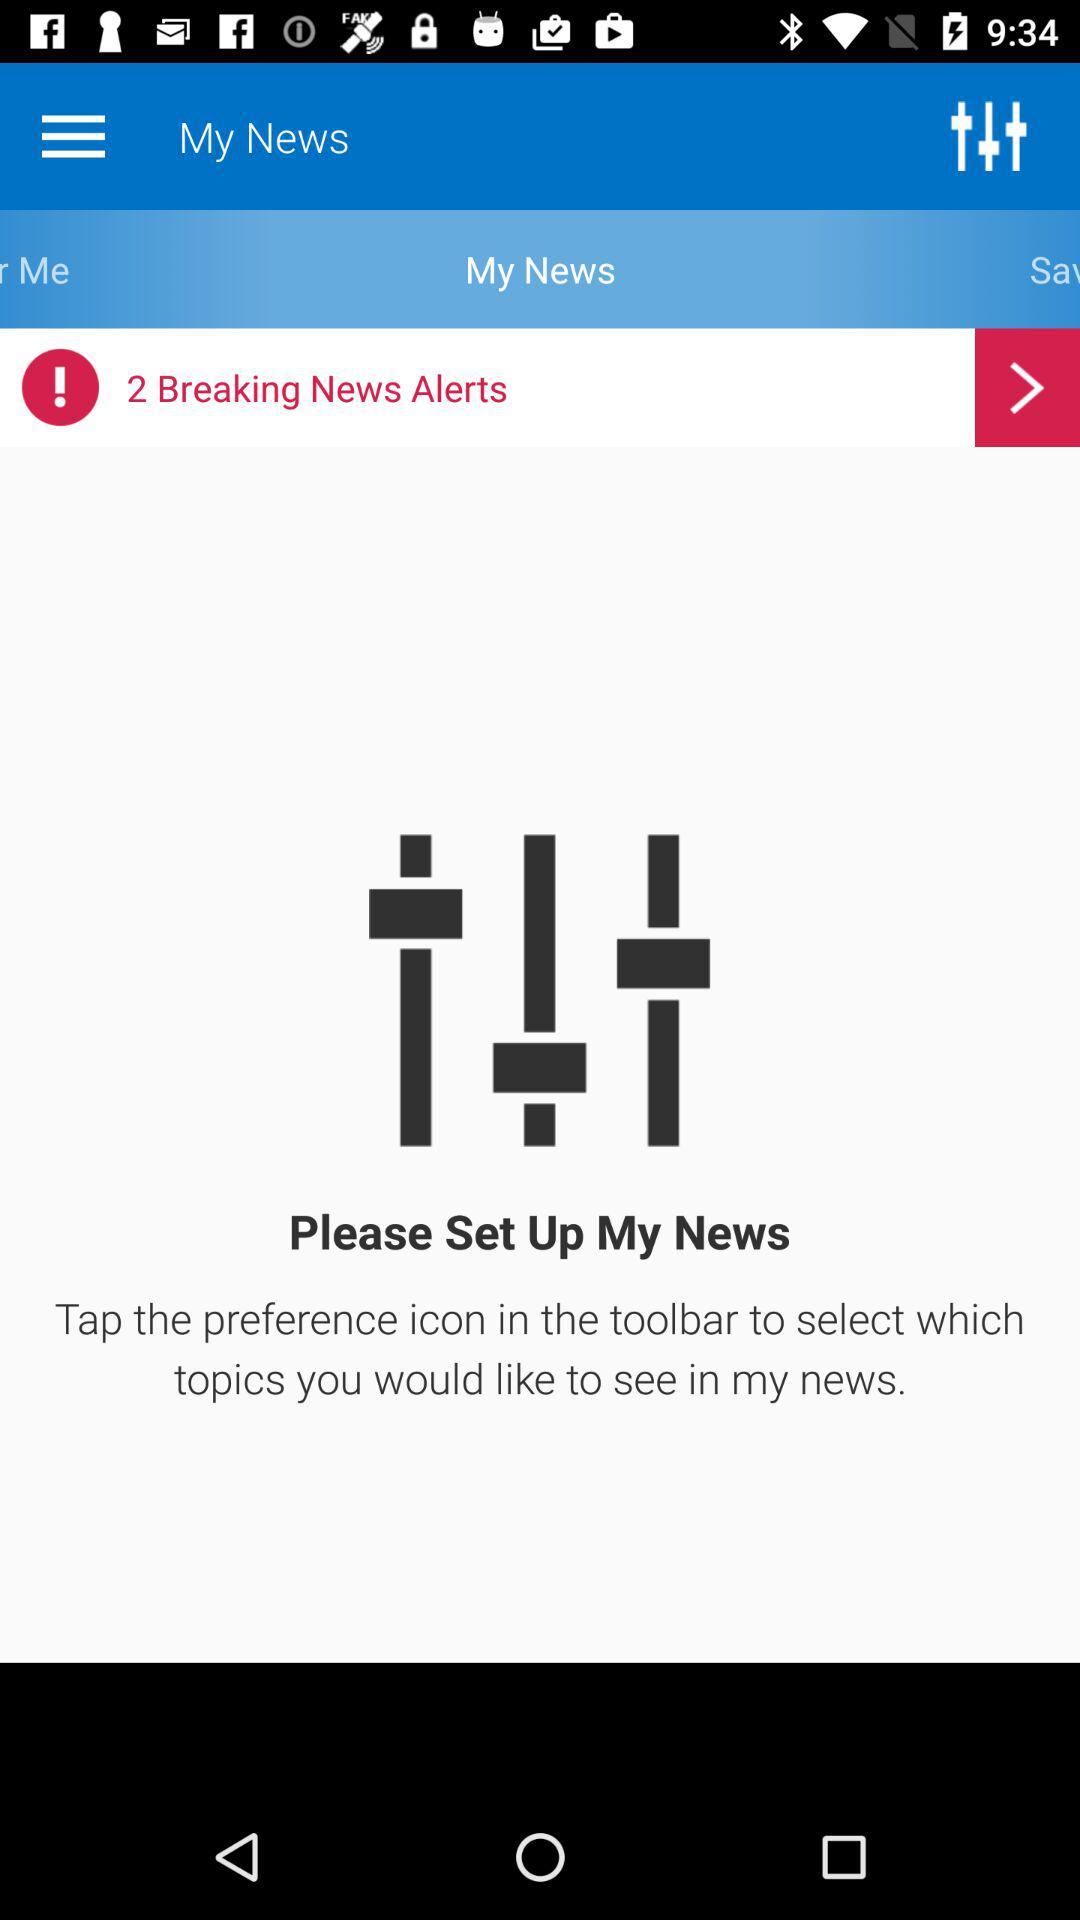What is the application name? The application name is "My News". 